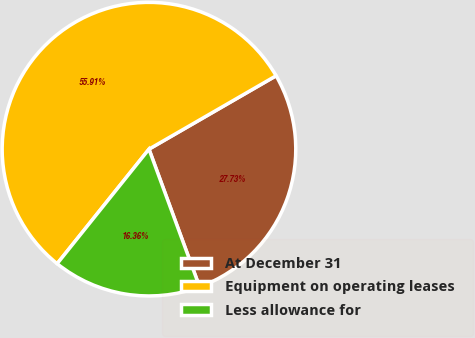Convert chart to OTSL. <chart><loc_0><loc_0><loc_500><loc_500><pie_chart><fcel>At December 31<fcel>Equipment on operating leases<fcel>Less allowance for<nl><fcel>27.73%<fcel>55.91%<fcel>16.36%<nl></chart> 